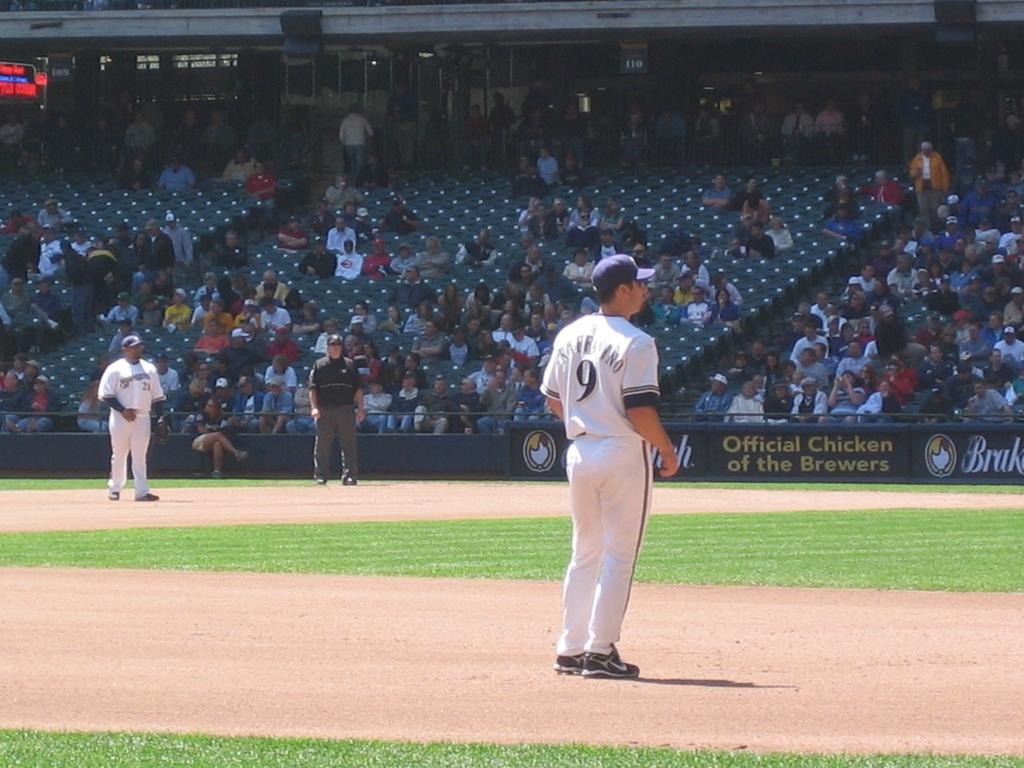What is the player number of this player at the front?
Your response must be concise. 9. What team is mentioned on the black advertisement on the wall?
Your response must be concise. Brewers. 